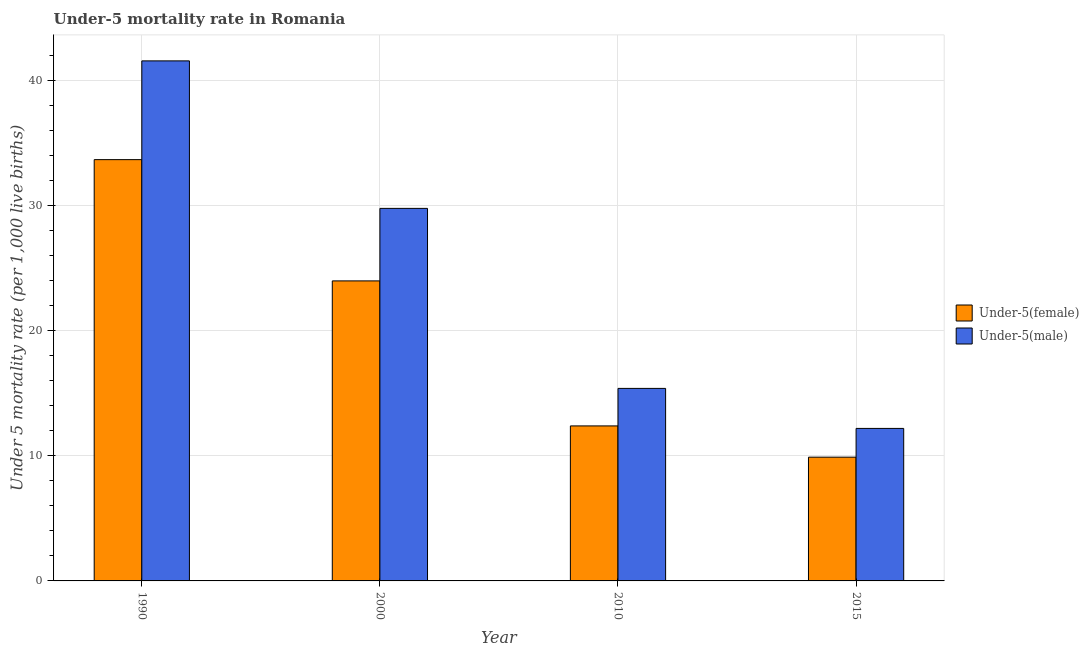How many groups of bars are there?
Offer a very short reply. 4. Are the number of bars per tick equal to the number of legend labels?
Offer a terse response. Yes. How many bars are there on the 3rd tick from the left?
Provide a succinct answer. 2. What is the label of the 4th group of bars from the left?
Make the answer very short. 2015. What is the under-5 male mortality rate in 2015?
Keep it short and to the point. 12.2. Across all years, what is the maximum under-5 female mortality rate?
Offer a very short reply. 33.7. In which year was the under-5 male mortality rate minimum?
Your answer should be very brief. 2015. What is the total under-5 male mortality rate in the graph?
Keep it short and to the point. 99. What is the difference between the under-5 female mortality rate in 1990 and that in 2015?
Provide a succinct answer. 23.8. What is the difference between the under-5 female mortality rate in 2015 and the under-5 male mortality rate in 2000?
Offer a very short reply. -14.1. What is the average under-5 male mortality rate per year?
Offer a very short reply. 24.75. What is the ratio of the under-5 female mortality rate in 1990 to that in 2010?
Your answer should be compact. 2.72. Is the difference between the under-5 female mortality rate in 2000 and 2010 greater than the difference between the under-5 male mortality rate in 2000 and 2010?
Ensure brevity in your answer.  No. What is the difference between the highest and the second highest under-5 female mortality rate?
Make the answer very short. 9.7. What is the difference between the highest and the lowest under-5 female mortality rate?
Offer a very short reply. 23.8. In how many years, is the under-5 female mortality rate greater than the average under-5 female mortality rate taken over all years?
Ensure brevity in your answer.  2. What does the 1st bar from the left in 1990 represents?
Your answer should be very brief. Under-5(female). What does the 1st bar from the right in 2000 represents?
Offer a very short reply. Under-5(male). Does the graph contain grids?
Ensure brevity in your answer.  Yes. How are the legend labels stacked?
Provide a succinct answer. Vertical. What is the title of the graph?
Give a very brief answer. Under-5 mortality rate in Romania. What is the label or title of the Y-axis?
Provide a succinct answer. Under 5 mortality rate (per 1,0 live births). What is the Under 5 mortality rate (per 1,000 live births) in Under-5(female) in 1990?
Offer a very short reply. 33.7. What is the Under 5 mortality rate (per 1,000 live births) of Under-5(male) in 1990?
Offer a very short reply. 41.6. What is the Under 5 mortality rate (per 1,000 live births) of Under-5(female) in 2000?
Offer a very short reply. 24. What is the Under 5 mortality rate (per 1,000 live births) of Under-5(male) in 2000?
Your response must be concise. 29.8. What is the Under 5 mortality rate (per 1,000 live births) of Under-5(female) in 2010?
Ensure brevity in your answer.  12.4. What is the Under 5 mortality rate (per 1,000 live births) of Under-5(male) in 2010?
Give a very brief answer. 15.4. What is the Under 5 mortality rate (per 1,000 live births) of Under-5(female) in 2015?
Offer a very short reply. 9.9. Across all years, what is the maximum Under 5 mortality rate (per 1,000 live births) in Under-5(female)?
Keep it short and to the point. 33.7. Across all years, what is the maximum Under 5 mortality rate (per 1,000 live births) of Under-5(male)?
Give a very brief answer. 41.6. Across all years, what is the minimum Under 5 mortality rate (per 1,000 live births) of Under-5(female)?
Your response must be concise. 9.9. What is the difference between the Under 5 mortality rate (per 1,000 live births) of Under-5(male) in 1990 and that in 2000?
Your response must be concise. 11.8. What is the difference between the Under 5 mortality rate (per 1,000 live births) in Under-5(female) in 1990 and that in 2010?
Offer a very short reply. 21.3. What is the difference between the Under 5 mortality rate (per 1,000 live births) in Under-5(male) in 1990 and that in 2010?
Make the answer very short. 26.2. What is the difference between the Under 5 mortality rate (per 1,000 live births) of Under-5(female) in 1990 and that in 2015?
Your answer should be compact. 23.8. What is the difference between the Under 5 mortality rate (per 1,000 live births) of Under-5(male) in 1990 and that in 2015?
Your answer should be compact. 29.4. What is the difference between the Under 5 mortality rate (per 1,000 live births) in Under-5(female) in 2000 and that in 2010?
Offer a terse response. 11.6. What is the difference between the Under 5 mortality rate (per 1,000 live births) of Under-5(male) in 2000 and that in 2010?
Provide a succinct answer. 14.4. What is the difference between the Under 5 mortality rate (per 1,000 live births) in Under-5(female) in 2000 and that in 2015?
Offer a terse response. 14.1. What is the difference between the Under 5 mortality rate (per 1,000 live births) in Under-5(male) in 2010 and that in 2015?
Your answer should be compact. 3.2. What is the difference between the Under 5 mortality rate (per 1,000 live births) in Under-5(female) in 1990 and the Under 5 mortality rate (per 1,000 live births) in Under-5(male) in 2015?
Offer a very short reply. 21.5. What is the difference between the Under 5 mortality rate (per 1,000 live births) of Under-5(female) in 2000 and the Under 5 mortality rate (per 1,000 live births) of Under-5(male) in 2010?
Make the answer very short. 8.6. What is the difference between the Under 5 mortality rate (per 1,000 live births) in Under-5(female) in 2000 and the Under 5 mortality rate (per 1,000 live births) in Under-5(male) in 2015?
Provide a succinct answer. 11.8. What is the average Under 5 mortality rate (per 1,000 live births) of Under-5(female) per year?
Your response must be concise. 20. What is the average Under 5 mortality rate (per 1,000 live births) in Under-5(male) per year?
Make the answer very short. 24.75. In the year 1990, what is the difference between the Under 5 mortality rate (per 1,000 live births) of Under-5(female) and Under 5 mortality rate (per 1,000 live births) of Under-5(male)?
Provide a short and direct response. -7.9. In the year 2010, what is the difference between the Under 5 mortality rate (per 1,000 live births) of Under-5(female) and Under 5 mortality rate (per 1,000 live births) of Under-5(male)?
Provide a succinct answer. -3. In the year 2015, what is the difference between the Under 5 mortality rate (per 1,000 live births) in Under-5(female) and Under 5 mortality rate (per 1,000 live births) in Under-5(male)?
Provide a succinct answer. -2.3. What is the ratio of the Under 5 mortality rate (per 1,000 live births) of Under-5(female) in 1990 to that in 2000?
Keep it short and to the point. 1.4. What is the ratio of the Under 5 mortality rate (per 1,000 live births) of Under-5(male) in 1990 to that in 2000?
Give a very brief answer. 1.4. What is the ratio of the Under 5 mortality rate (per 1,000 live births) in Under-5(female) in 1990 to that in 2010?
Make the answer very short. 2.72. What is the ratio of the Under 5 mortality rate (per 1,000 live births) in Under-5(male) in 1990 to that in 2010?
Ensure brevity in your answer.  2.7. What is the ratio of the Under 5 mortality rate (per 1,000 live births) of Under-5(female) in 1990 to that in 2015?
Your answer should be compact. 3.4. What is the ratio of the Under 5 mortality rate (per 1,000 live births) in Under-5(male) in 1990 to that in 2015?
Offer a terse response. 3.41. What is the ratio of the Under 5 mortality rate (per 1,000 live births) of Under-5(female) in 2000 to that in 2010?
Your answer should be compact. 1.94. What is the ratio of the Under 5 mortality rate (per 1,000 live births) of Under-5(male) in 2000 to that in 2010?
Make the answer very short. 1.94. What is the ratio of the Under 5 mortality rate (per 1,000 live births) in Under-5(female) in 2000 to that in 2015?
Your response must be concise. 2.42. What is the ratio of the Under 5 mortality rate (per 1,000 live births) in Under-5(male) in 2000 to that in 2015?
Provide a short and direct response. 2.44. What is the ratio of the Under 5 mortality rate (per 1,000 live births) in Under-5(female) in 2010 to that in 2015?
Your answer should be very brief. 1.25. What is the ratio of the Under 5 mortality rate (per 1,000 live births) of Under-5(male) in 2010 to that in 2015?
Your answer should be very brief. 1.26. What is the difference between the highest and the second highest Under 5 mortality rate (per 1,000 live births) of Under-5(female)?
Your answer should be compact. 9.7. What is the difference between the highest and the lowest Under 5 mortality rate (per 1,000 live births) in Under-5(female)?
Your answer should be very brief. 23.8. What is the difference between the highest and the lowest Under 5 mortality rate (per 1,000 live births) of Under-5(male)?
Offer a very short reply. 29.4. 